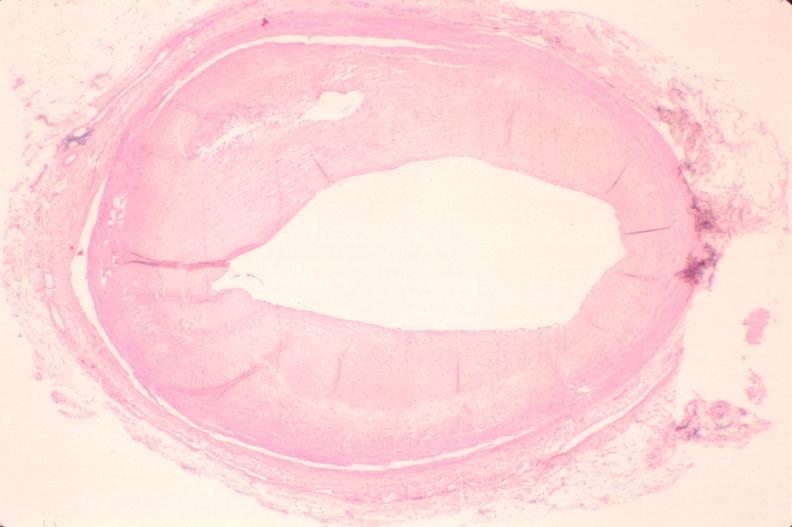does adenocarcinoma show atherosclerosis?
Answer the question using a single word or phrase. No 